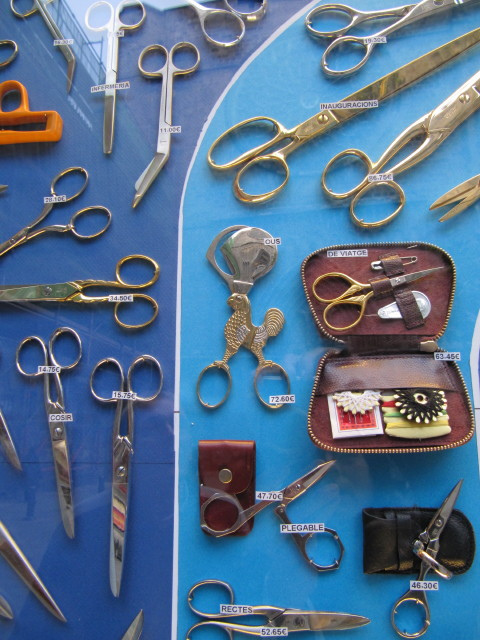Please transcribe the text information in this image. 7260C 47.70C PLEGABLE 46.30C 52.65C RECTES 15.75 14.76C 63.45C 